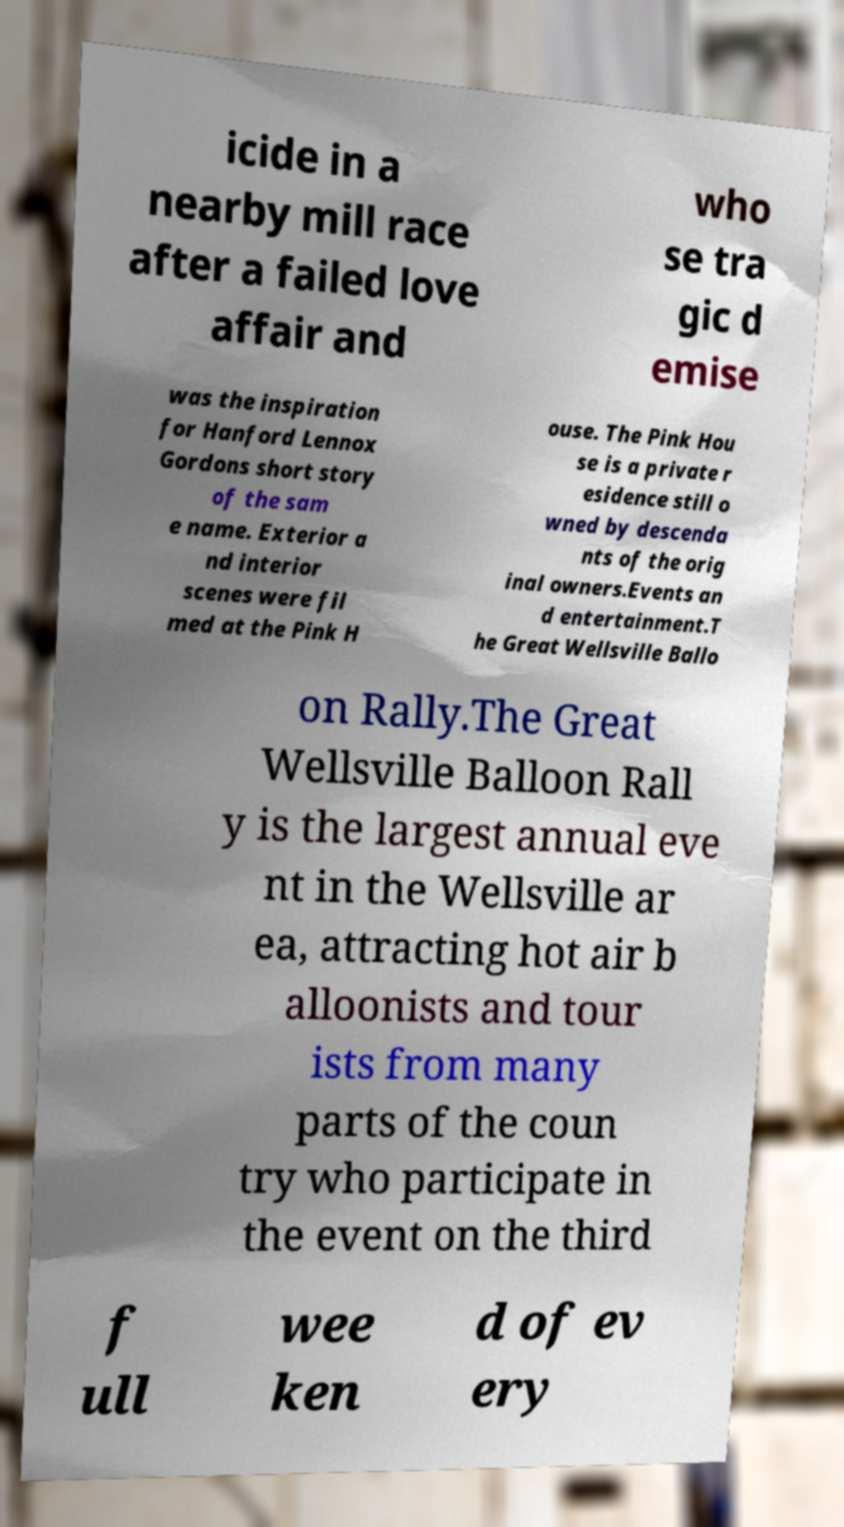Could you extract and type out the text from this image? icide in a nearby mill race after a failed love affair and who se tra gic d emise was the inspiration for Hanford Lennox Gordons short story of the sam e name. Exterior a nd interior scenes were fil med at the Pink H ouse. The Pink Hou se is a private r esidence still o wned by descenda nts of the orig inal owners.Events an d entertainment.T he Great Wellsville Ballo on Rally.The Great Wellsville Balloon Rall y is the largest annual eve nt in the Wellsville ar ea, attracting hot air b alloonists and tour ists from many parts of the coun try who participate in the event on the third f ull wee ken d of ev ery 